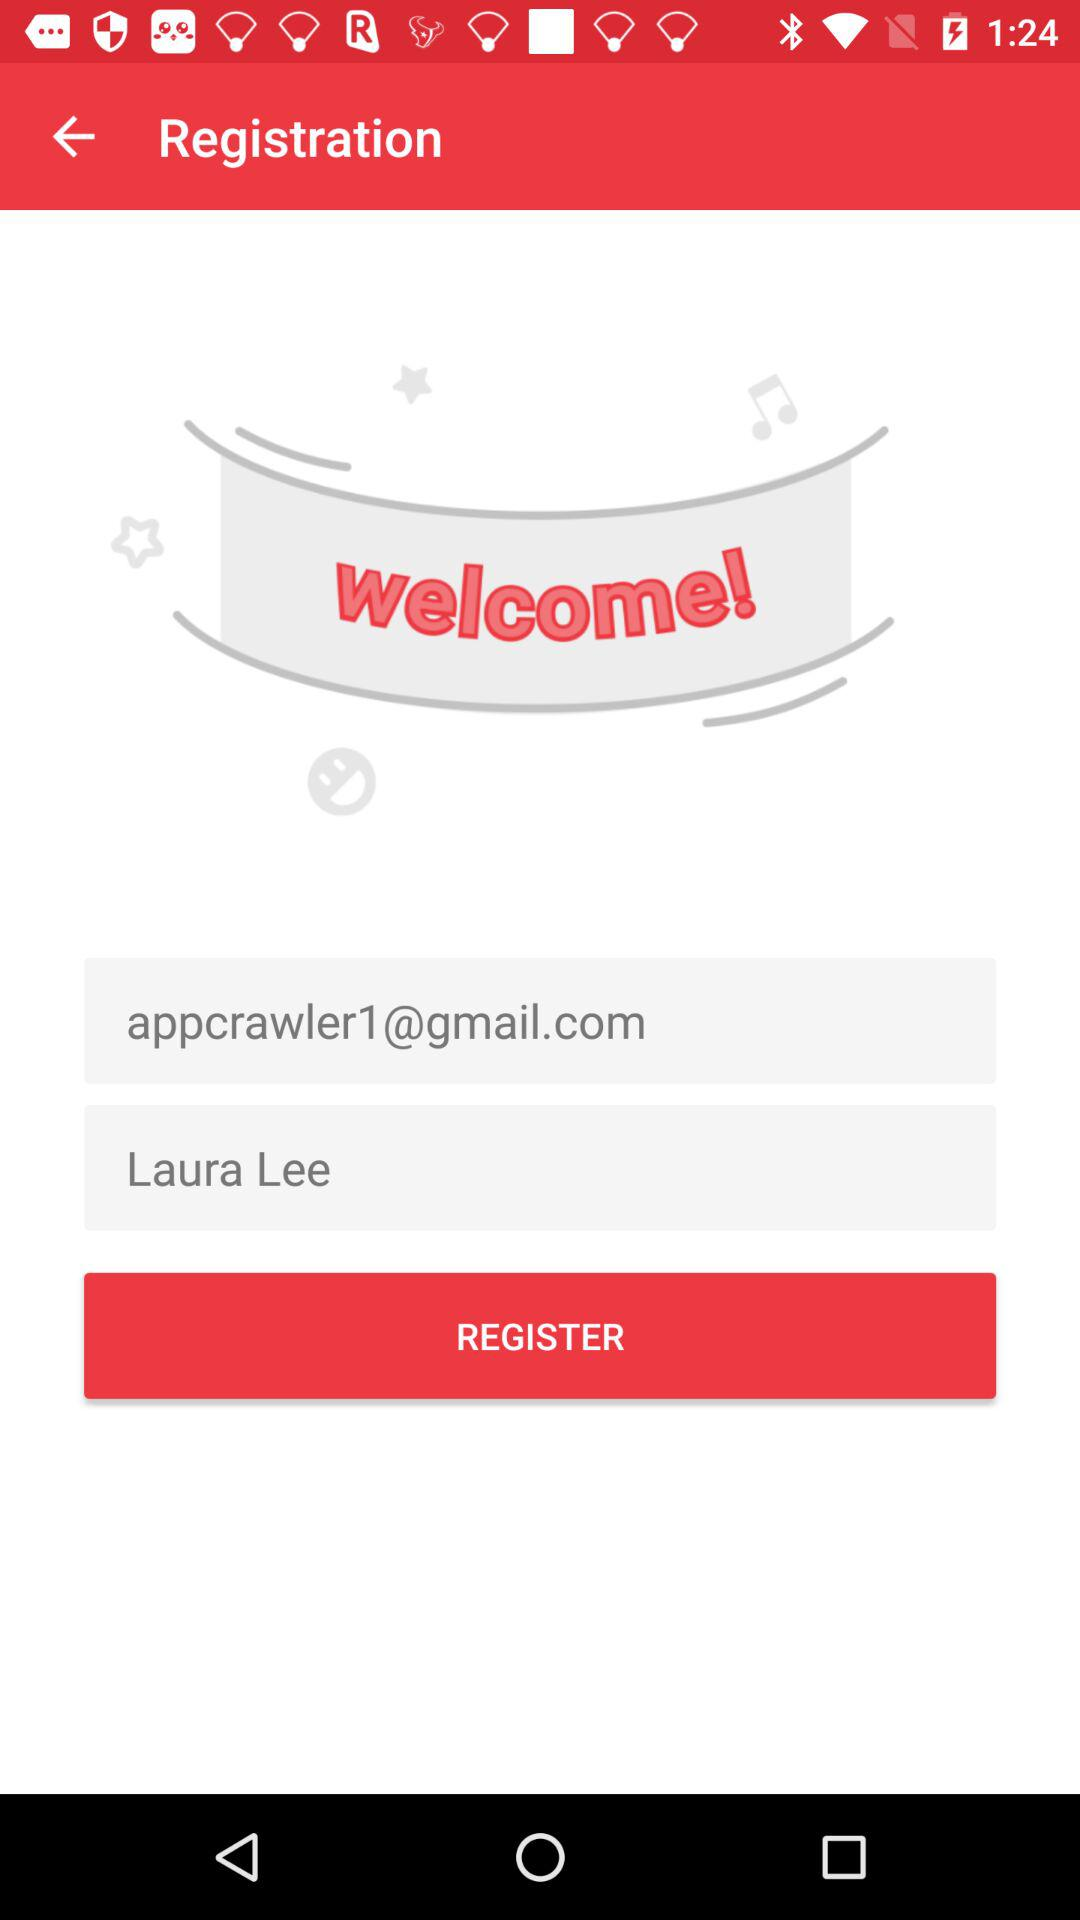What is the email address? The email address is appcrawler1@gmail.com. 